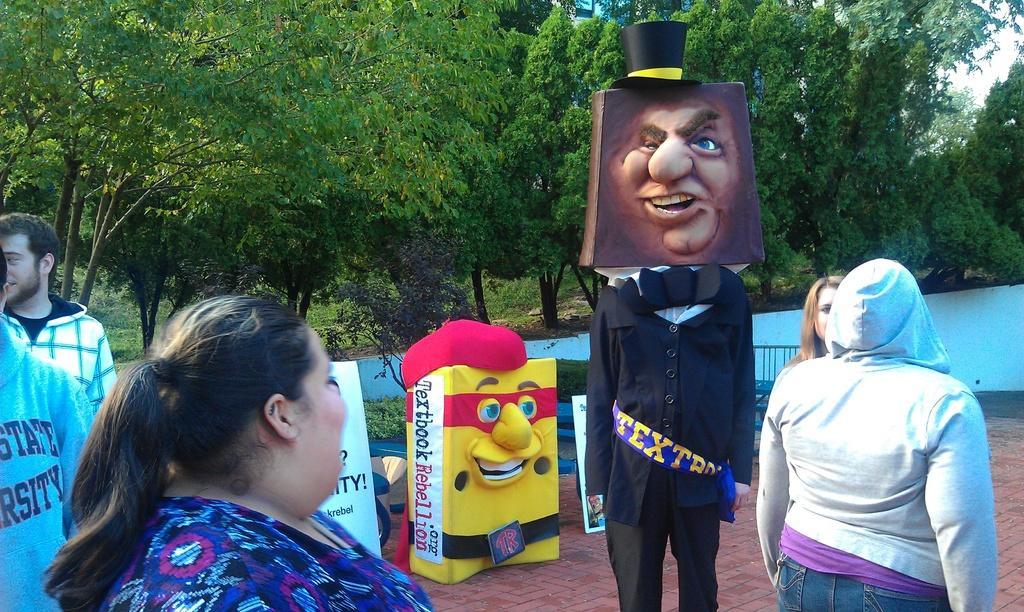How would you summarize this image in a sentence or two? In this image we can see these people are walking on the ground. Here we can see this person wearing different costume and here we can see the wall, some objects and trees in the background. 